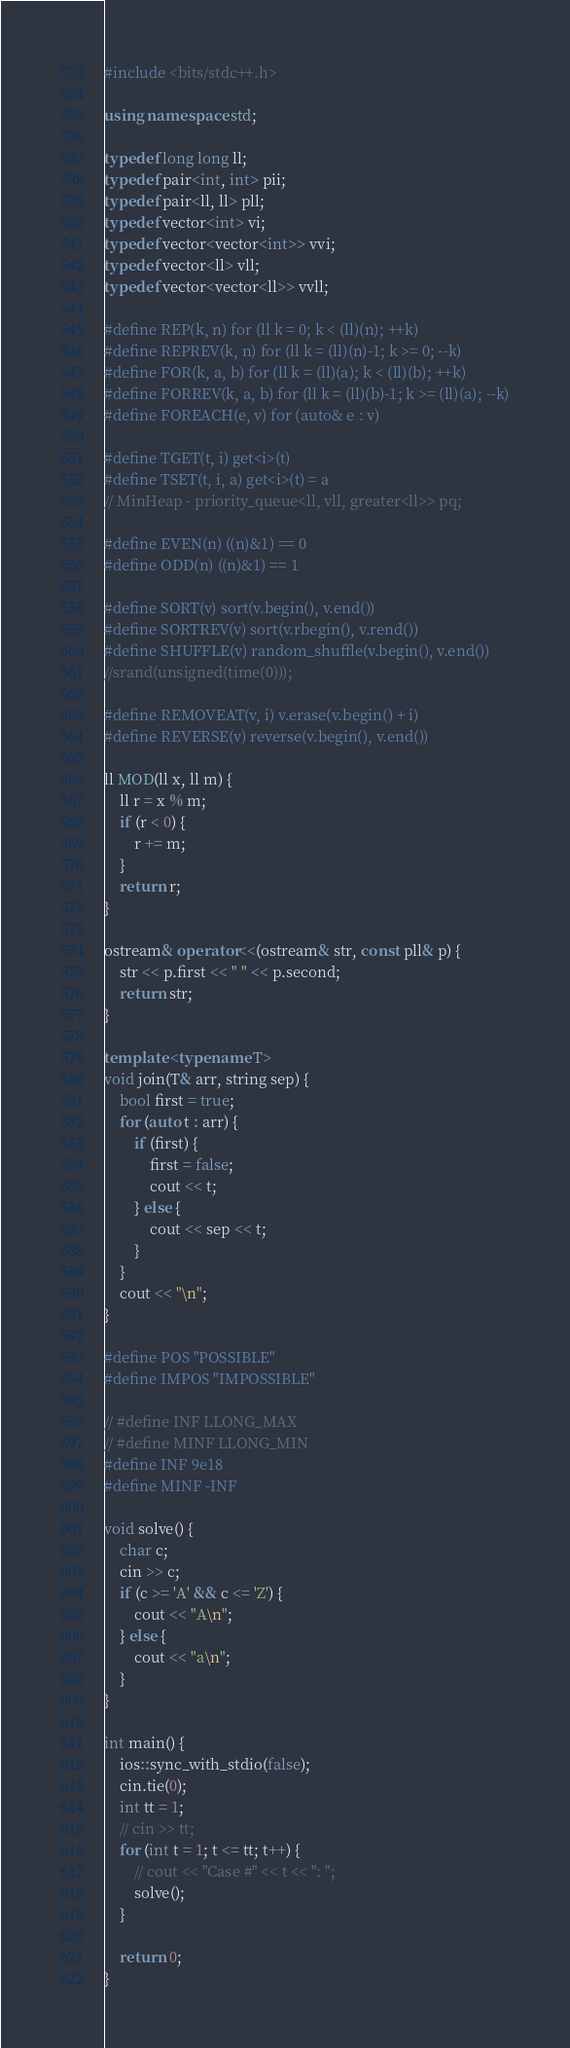Convert code to text. <code><loc_0><loc_0><loc_500><loc_500><_C++_>#include <bits/stdc++.h>

using namespace std;

typedef long long ll;
typedef pair<int, int> pii;
typedef pair<ll, ll> pll;
typedef vector<int> vi;
typedef vector<vector<int>> vvi;
typedef vector<ll> vll;
typedef vector<vector<ll>> vvll;

#define REP(k, n) for (ll k = 0; k < (ll)(n); ++k)
#define REPREV(k, n) for (ll k = (ll)(n)-1; k >= 0; --k)
#define FOR(k, a, b) for (ll k = (ll)(a); k < (ll)(b); ++k)
#define FORREV(k, a, b) for (ll k = (ll)(b)-1; k >= (ll)(a); --k)
#define FOREACH(e, v) for (auto& e : v)

#define TGET(t, i) get<i>(t)
#define TSET(t, i, a) get<i>(t) = a
// MinHeap - priority_queue<ll, vll, greater<ll>> pq;

#define EVEN(n) ((n)&1) == 0
#define ODD(n) ((n)&1) == 1

#define SORT(v) sort(v.begin(), v.end())
#define SORTREV(v) sort(v.rbegin(), v.rend())
#define SHUFFLE(v) random_shuffle(v.begin(), v.end())
//srand(unsigned(time(0)));

#define REMOVEAT(v, i) v.erase(v.begin() + i)
#define REVERSE(v) reverse(v.begin(), v.end())

ll MOD(ll x, ll m) {
    ll r = x % m;
    if (r < 0) {
        r += m;
    }
    return r;
}

ostream& operator<<(ostream& str, const pll& p) {
    str << p.first << " " << p.second;
    return str;
}

template <typename T>
void join(T& arr, string sep) {
    bool first = true;
    for (auto t : arr) {
        if (first) {
            first = false;
            cout << t;
        } else {
            cout << sep << t;
        }
    }
    cout << "\n";
}

#define POS "POSSIBLE"
#define IMPOS "IMPOSSIBLE"

// #define INF LLONG_MAX
// #define MINF LLONG_MIN
#define INF 9e18
#define MINF -INF

void solve() {
    char c;
    cin >> c;
    if (c >= 'A' && c <= 'Z') {
        cout << "A\n";
    } else {
        cout << "a\n";
    }
}

int main() {
    ios::sync_with_stdio(false);
    cin.tie(0);
    int tt = 1;
    // cin >> tt;
    for (int t = 1; t <= tt; t++) {
        // cout << "Case #" << t << ": ";
        solve();
    }

    return 0;
}</code> 